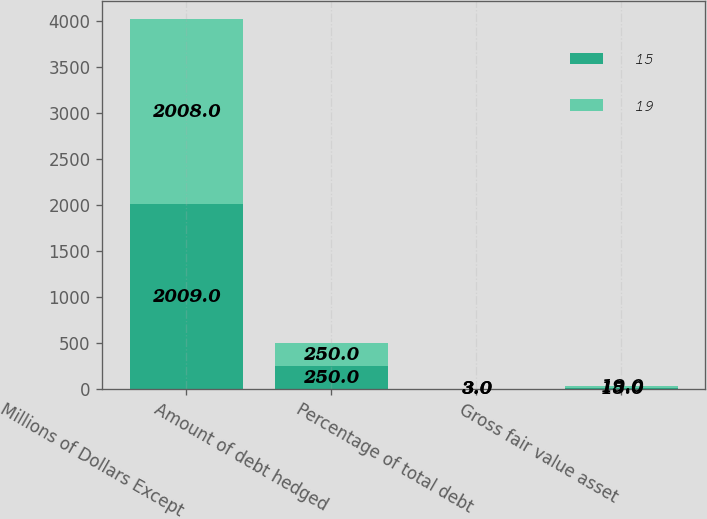Convert chart. <chart><loc_0><loc_0><loc_500><loc_500><stacked_bar_chart><ecel><fcel>Millions of Dollars Except<fcel>Amount of debt hedged<fcel>Percentage of total debt<fcel>Gross fair value asset<nl><fcel>15<fcel>2009<fcel>250<fcel>3<fcel>15<nl><fcel>19<fcel>2008<fcel>250<fcel>3<fcel>19<nl></chart> 